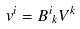<formula> <loc_0><loc_0><loc_500><loc_500>v ^ { i } = { { B } ^ { i } } _ { k } V ^ { k }</formula> 